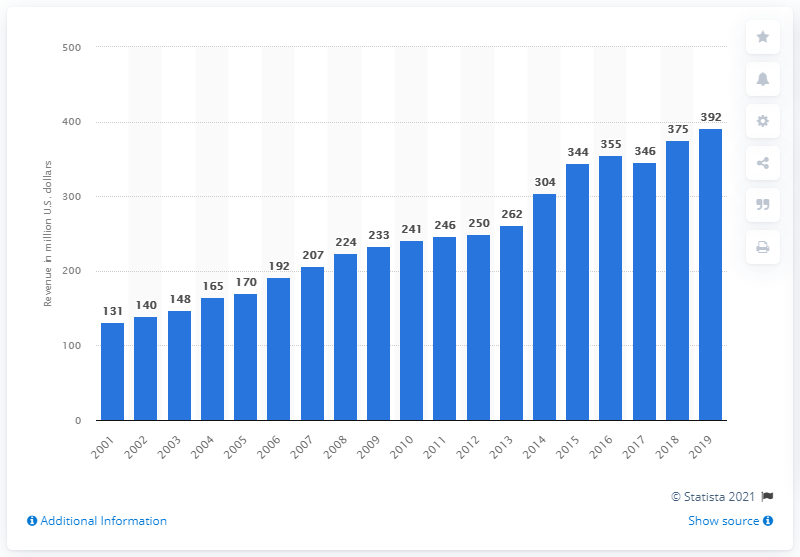Indicate a few pertinent items in this graphic. The revenue of the Los Angeles Chargers in 2019 was 392. 